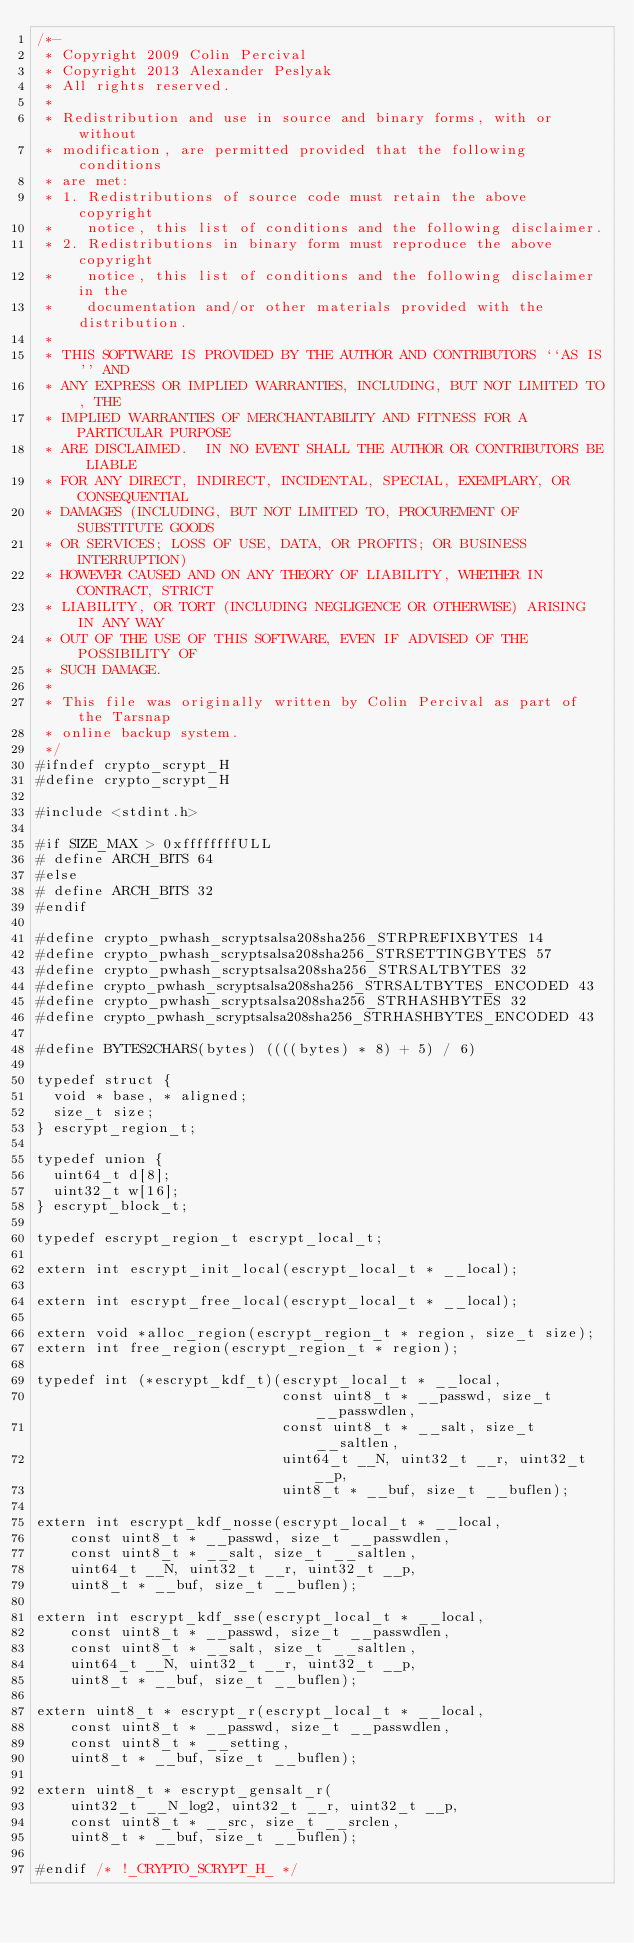<code> <loc_0><loc_0><loc_500><loc_500><_C_>/*-
 * Copyright 2009 Colin Percival
 * Copyright 2013 Alexander Peslyak
 * All rights reserved.
 *
 * Redistribution and use in source and binary forms, with or without
 * modification, are permitted provided that the following conditions
 * are met:
 * 1. Redistributions of source code must retain the above copyright
 *    notice, this list of conditions and the following disclaimer.
 * 2. Redistributions in binary form must reproduce the above copyright
 *    notice, this list of conditions and the following disclaimer in the
 *    documentation and/or other materials provided with the distribution.
 *
 * THIS SOFTWARE IS PROVIDED BY THE AUTHOR AND CONTRIBUTORS ``AS IS'' AND
 * ANY EXPRESS OR IMPLIED WARRANTIES, INCLUDING, BUT NOT LIMITED TO, THE
 * IMPLIED WARRANTIES OF MERCHANTABILITY AND FITNESS FOR A PARTICULAR PURPOSE
 * ARE DISCLAIMED.  IN NO EVENT SHALL THE AUTHOR OR CONTRIBUTORS BE LIABLE
 * FOR ANY DIRECT, INDIRECT, INCIDENTAL, SPECIAL, EXEMPLARY, OR CONSEQUENTIAL
 * DAMAGES (INCLUDING, BUT NOT LIMITED TO, PROCUREMENT OF SUBSTITUTE GOODS
 * OR SERVICES; LOSS OF USE, DATA, OR PROFITS; OR BUSINESS INTERRUPTION)
 * HOWEVER CAUSED AND ON ANY THEORY OF LIABILITY, WHETHER IN CONTRACT, STRICT
 * LIABILITY, OR TORT (INCLUDING NEGLIGENCE OR OTHERWISE) ARISING IN ANY WAY
 * OUT OF THE USE OF THIS SOFTWARE, EVEN IF ADVISED OF THE POSSIBILITY OF
 * SUCH DAMAGE.
 *
 * This file was originally written by Colin Percival as part of the Tarsnap
 * online backup system.
 */
#ifndef crypto_scrypt_H
#define crypto_scrypt_H

#include <stdint.h>

#if SIZE_MAX > 0xffffffffULL
# define ARCH_BITS 64
#else
# define ARCH_BITS 32
#endif

#define crypto_pwhash_scryptsalsa208sha256_STRPREFIXBYTES 14
#define crypto_pwhash_scryptsalsa208sha256_STRSETTINGBYTES 57
#define crypto_pwhash_scryptsalsa208sha256_STRSALTBYTES 32
#define crypto_pwhash_scryptsalsa208sha256_STRSALTBYTES_ENCODED 43
#define crypto_pwhash_scryptsalsa208sha256_STRHASHBYTES 32
#define crypto_pwhash_scryptsalsa208sha256_STRHASHBYTES_ENCODED 43

#define BYTES2CHARS(bytes) ((((bytes) * 8) + 5) / 6)

typedef struct {
	void * base, * aligned;
	size_t size;
} escrypt_region_t;

typedef union {
	uint64_t d[8];
	uint32_t w[16];
} escrypt_block_t;

typedef escrypt_region_t escrypt_local_t;

extern int escrypt_init_local(escrypt_local_t * __local);

extern int escrypt_free_local(escrypt_local_t * __local);

extern void *alloc_region(escrypt_region_t * region, size_t size);
extern int free_region(escrypt_region_t * region);

typedef int (*escrypt_kdf_t)(escrypt_local_t * __local,
                             const uint8_t * __passwd, size_t __passwdlen,
                             const uint8_t * __salt, size_t __saltlen,
                             uint64_t __N, uint32_t __r, uint32_t __p,
                             uint8_t * __buf, size_t __buflen);

extern int escrypt_kdf_nosse(escrypt_local_t * __local,
    const uint8_t * __passwd, size_t __passwdlen,
    const uint8_t * __salt, size_t __saltlen,
    uint64_t __N, uint32_t __r, uint32_t __p,
    uint8_t * __buf, size_t __buflen);

extern int escrypt_kdf_sse(escrypt_local_t * __local,
    const uint8_t * __passwd, size_t __passwdlen,
    const uint8_t * __salt, size_t __saltlen,
    uint64_t __N, uint32_t __r, uint32_t __p,
    uint8_t * __buf, size_t __buflen);

extern uint8_t * escrypt_r(escrypt_local_t * __local,
    const uint8_t * __passwd, size_t __passwdlen,
    const uint8_t * __setting,
    uint8_t * __buf, size_t __buflen);

extern uint8_t * escrypt_gensalt_r(
    uint32_t __N_log2, uint32_t __r, uint32_t __p,
    const uint8_t * __src, size_t __srclen,
    uint8_t * __buf, size_t __buflen);

#endif /* !_CRYPTO_SCRYPT_H_ */
</code> 